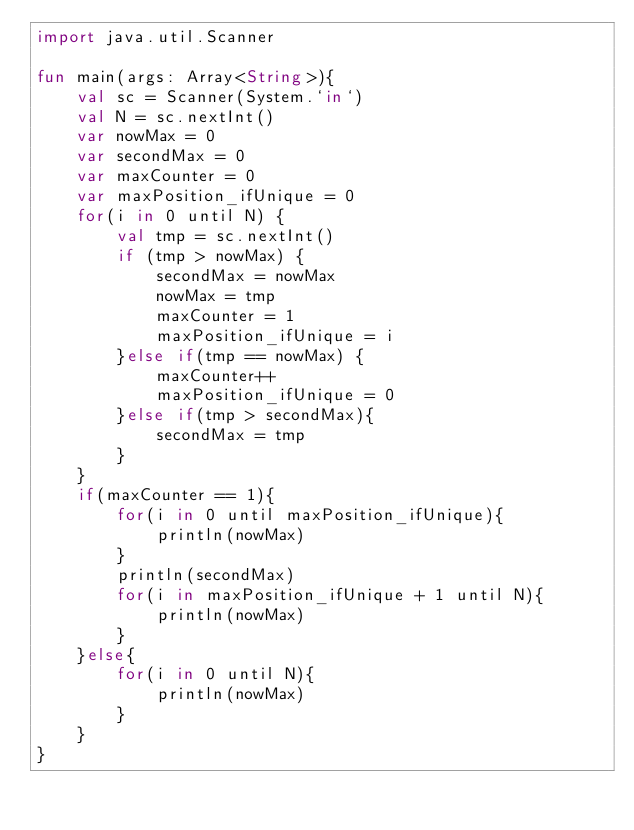Convert code to text. <code><loc_0><loc_0><loc_500><loc_500><_Kotlin_>import java.util.Scanner

fun main(args: Array<String>){
    val sc = Scanner(System.`in`)
    val N = sc.nextInt()
    var nowMax = 0
    var secondMax = 0
    var maxCounter = 0
    var maxPosition_ifUnique = 0
    for(i in 0 until N) {
        val tmp = sc.nextInt()
        if (tmp > nowMax) {
            secondMax = nowMax
            nowMax = tmp
            maxCounter = 1
            maxPosition_ifUnique = i
        }else if(tmp == nowMax) {
            maxCounter++
            maxPosition_ifUnique = 0
        }else if(tmp > secondMax){
            secondMax = tmp
        }
    }
    if(maxCounter == 1){
        for(i in 0 until maxPosition_ifUnique){
            println(nowMax)
        }
        println(secondMax)
        for(i in maxPosition_ifUnique + 1 until N){
            println(nowMax)
        }
    }else{
        for(i in 0 until N){
            println(nowMax)
        }
    }
}</code> 